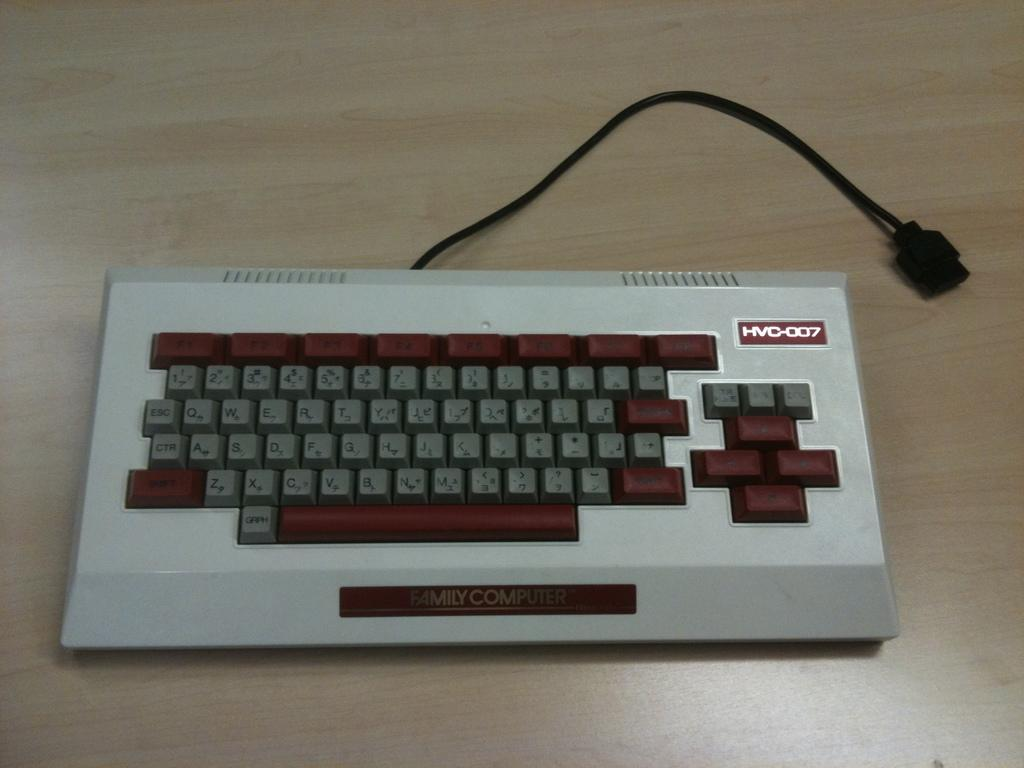<image>
Relay a brief, clear account of the picture shown. The bulky HVC-007 is placed on an otherwise empty table top. 